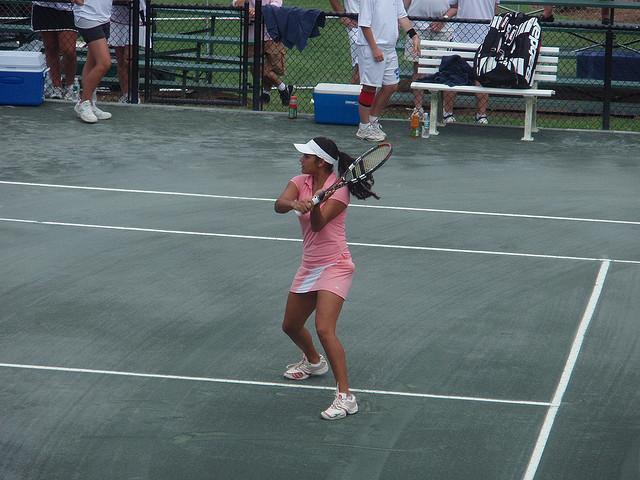How many people are visible?
Give a very brief answer. 6. How many dogs can be seen?
Give a very brief answer. 0. 